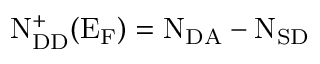<formula> <loc_0><loc_0><loc_500><loc_500>N _ { D D } ^ { + } ( E _ { F } ) = N _ { D A } - N _ { S D }</formula> 